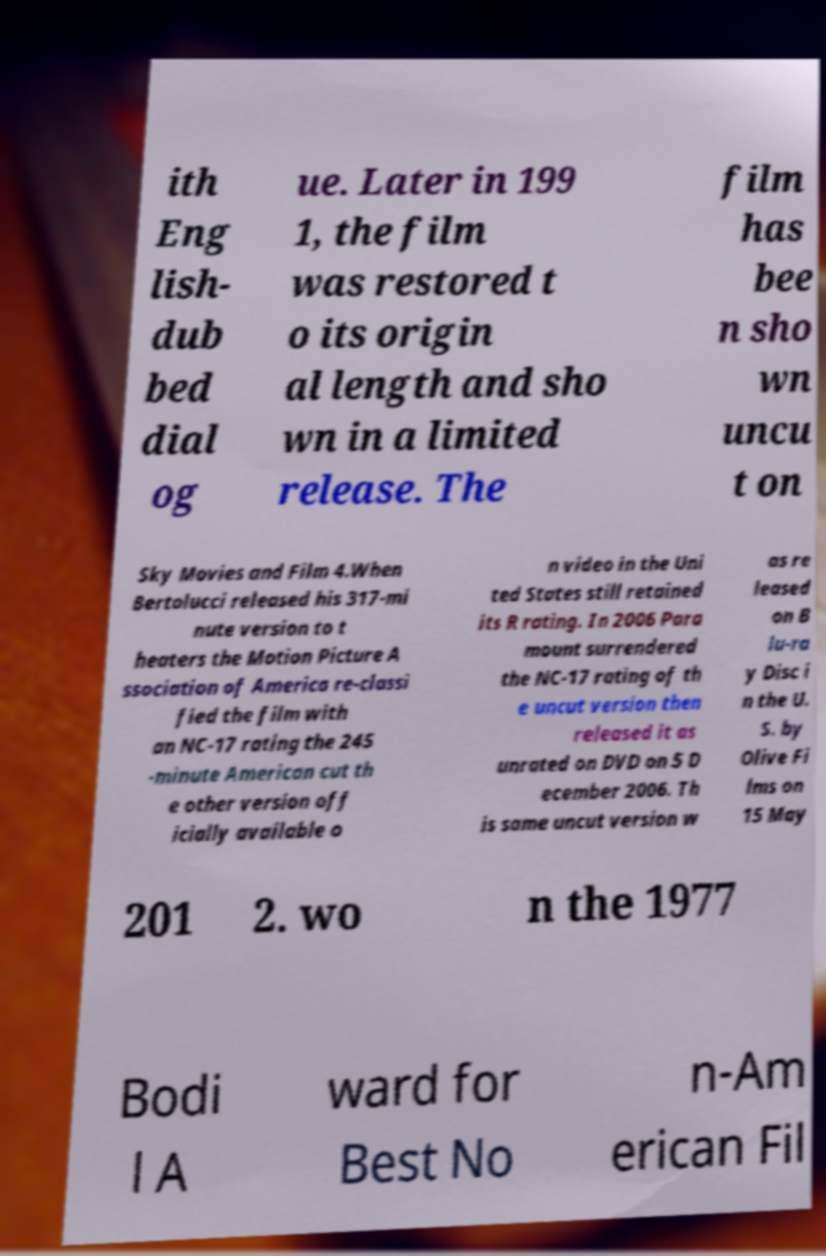There's text embedded in this image that I need extracted. Can you transcribe it verbatim? ith Eng lish- dub bed dial og ue. Later in 199 1, the film was restored t o its origin al length and sho wn in a limited release. The film has bee n sho wn uncu t on Sky Movies and Film 4.When Bertolucci released his 317-mi nute version to t heaters the Motion Picture A ssociation of America re-classi fied the film with an NC-17 rating the 245 -minute American cut th e other version off icially available o n video in the Uni ted States still retained its R rating. In 2006 Para mount surrendered the NC-17 rating of th e uncut version then released it as unrated on DVD on 5 D ecember 2006. Th is same uncut version w as re leased on B lu-ra y Disc i n the U. S. by Olive Fi lms on 15 May 201 2. wo n the 1977 Bodi l A ward for Best No n-Am erican Fil 